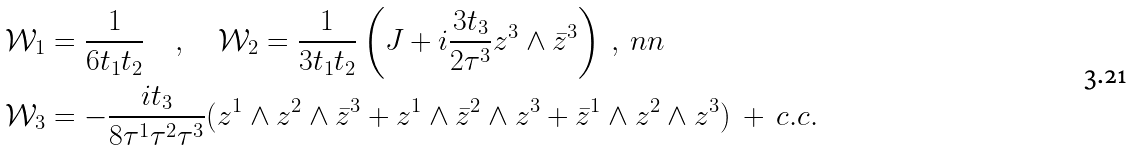<formula> <loc_0><loc_0><loc_500><loc_500>& \mathcal { W } _ { 1 } = \frac { 1 } { 6 t _ { 1 } t _ { 2 } } \quad , \quad \mathcal { W } _ { 2 } = \frac { 1 } { 3 t _ { 1 } t _ { 2 } } \left ( J + i \frac { 3 t _ { 3 } } { 2 \tau ^ { 3 } } z ^ { 3 } \wedge \bar { z } ^ { 3 } \right ) \ , \ n n \\ & \mathcal { W } _ { 3 } = - \frac { i t _ { 3 } } { 8 \tau ^ { 1 } \tau ^ { 2 } \tau ^ { 3 } } ( z ^ { 1 } \wedge z ^ { 2 } \wedge \bar { z } ^ { 3 } + z ^ { 1 } \wedge \bar { z } ^ { 2 } \wedge z ^ { 3 } + \bar { z } ^ { 1 } \wedge z ^ { 2 } \wedge z ^ { 3 } ) \ + \ c . c .</formula> 